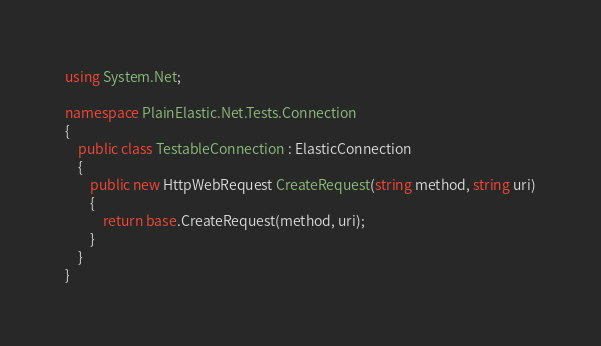<code> <loc_0><loc_0><loc_500><loc_500><_C#_>using System.Net;

namespace PlainElastic.Net.Tests.Connection
{
    public class TestableConnection : ElasticConnection
    {
        public new HttpWebRequest CreateRequest(string method, string uri)
        {
            return base.CreateRequest(method, uri);
        }
    }
}</code> 